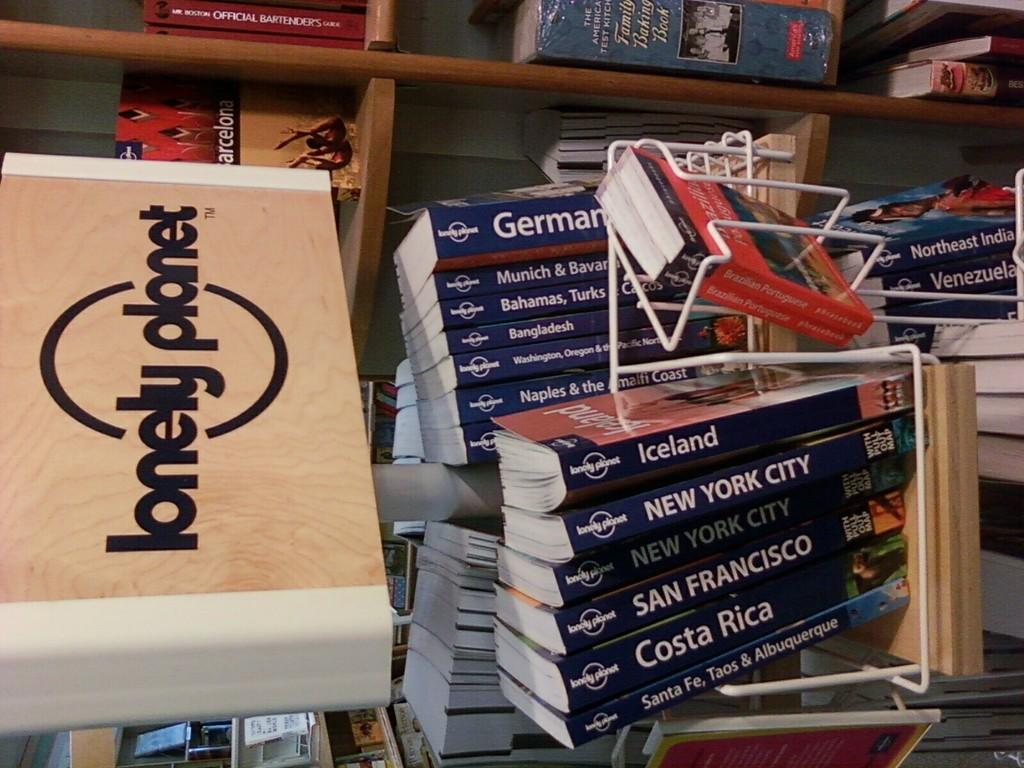<image>
Give a short and clear explanation of the subsequent image. Stacks of books sit together, one book contains information on Iceland. 